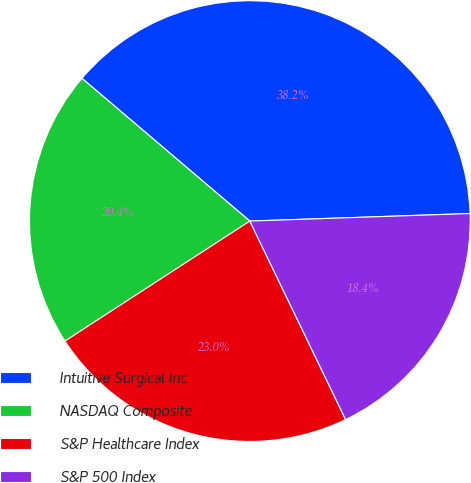Convert chart. <chart><loc_0><loc_0><loc_500><loc_500><pie_chart><fcel>Intuitive Surgical Inc<fcel>NASDAQ Composite<fcel>S&P Healthcare Index<fcel>S&P 500 Index<nl><fcel>38.24%<fcel>20.38%<fcel>22.99%<fcel>18.39%<nl></chart> 